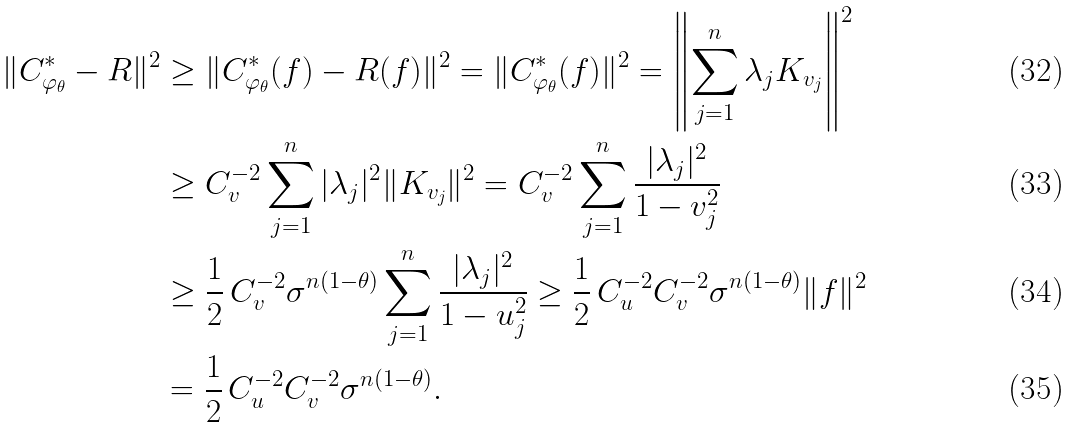<formula> <loc_0><loc_0><loc_500><loc_500>\| C _ { \varphi _ { \theta } } ^ { * } - R \| ^ { 2 } & \geq \| C _ { \varphi _ { \theta } } ^ { * } ( f ) - R ( f ) \| ^ { 2 } = \| C _ { \varphi _ { \theta } } ^ { * } ( f ) \| ^ { 2 } = \left \| \sum _ { j = 1 } ^ { n } \lambda _ { j } K _ { v _ { j } } \right \| ^ { 2 } \\ & \geq C _ { v } ^ { - 2 } \sum _ { j = 1 } ^ { n } | \lambda _ { j } | ^ { 2 } \| K _ { v _ { j } } \| ^ { 2 } = C _ { v } ^ { - 2 } \sum _ { j = 1 } ^ { n } \frac { | \lambda _ { j } | ^ { 2 } } { 1 - v _ { j } ^ { 2 } } \\ & \geq \frac { 1 } { 2 } \, C _ { v } ^ { - 2 } \sigma ^ { n ( 1 - \theta ) } \sum _ { j = 1 } ^ { n } \frac { | \lambda _ { j } | ^ { 2 } } { 1 - u _ { j } ^ { 2 } } \geq \frac { 1 } { 2 } \, C _ { u } ^ { - 2 } C _ { v } ^ { - 2 } \sigma ^ { n ( 1 - \theta ) } \| f \| ^ { 2 } \\ & = \frac { 1 } { 2 } \, C _ { u } ^ { - 2 } C _ { v } ^ { - 2 } \sigma ^ { n ( 1 - \theta ) } .</formula> 